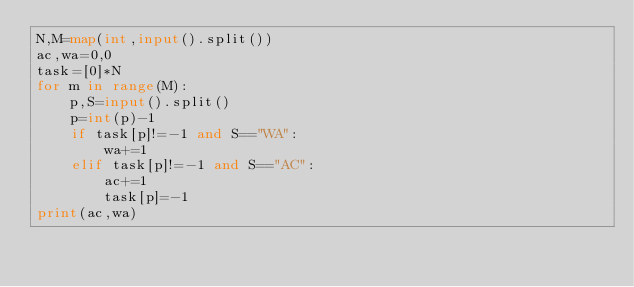Convert code to text. <code><loc_0><loc_0><loc_500><loc_500><_Python_>N,M=map(int,input().split())
ac,wa=0,0
task=[0]*N
for m in range(M):
    p,S=input().split()
    p=int(p)-1
    if task[p]!=-1 and S=="WA":
        wa+=1
    elif task[p]!=-1 and S=="AC":
        ac+=1
        task[p]=-1
print(ac,wa)
</code> 